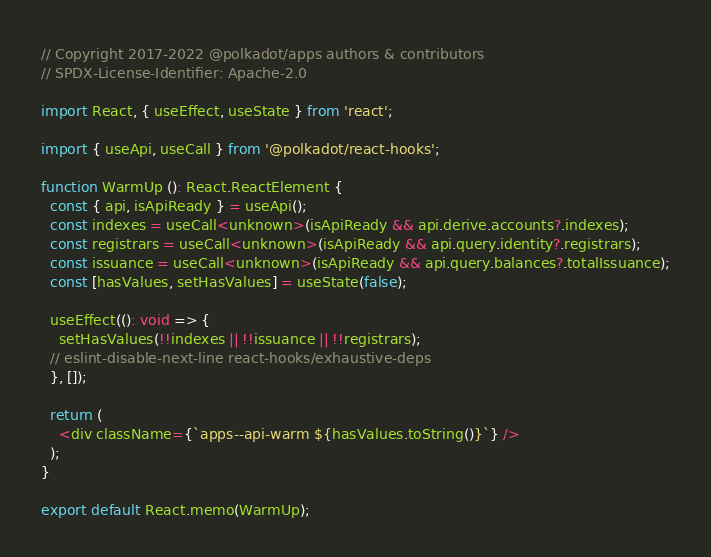<code> <loc_0><loc_0><loc_500><loc_500><_TypeScript_>// Copyright 2017-2022 @polkadot/apps authors & contributors
// SPDX-License-Identifier: Apache-2.0

import React, { useEffect, useState } from 'react';

import { useApi, useCall } from '@polkadot/react-hooks';

function WarmUp (): React.ReactElement {
  const { api, isApiReady } = useApi();
  const indexes = useCall<unknown>(isApiReady && api.derive.accounts?.indexes);
  const registrars = useCall<unknown>(isApiReady && api.query.identity?.registrars);
  const issuance = useCall<unknown>(isApiReady && api.query.balances?.totalIssuance);
  const [hasValues, setHasValues] = useState(false);

  useEffect((): void => {
    setHasValues(!!indexes || !!issuance || !!registrars);
  // eslint-disable-next-line react-hooks/exhaustive-deps
  }, []);

  return (
    <div className={`apps--api-warm ${hasValues.toString()}`} />
  );
}

export default React.memo(WarmUp);
</code> 